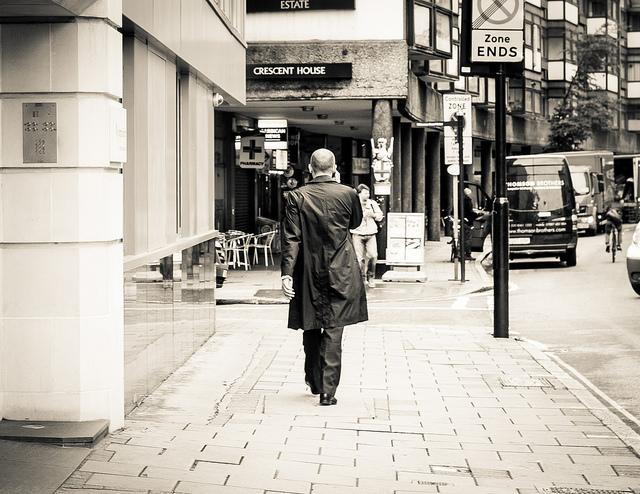During what time of day are the pedestrians walking on this sidewalk? Please explain your reasoning. morning. Its still dull and cold. 